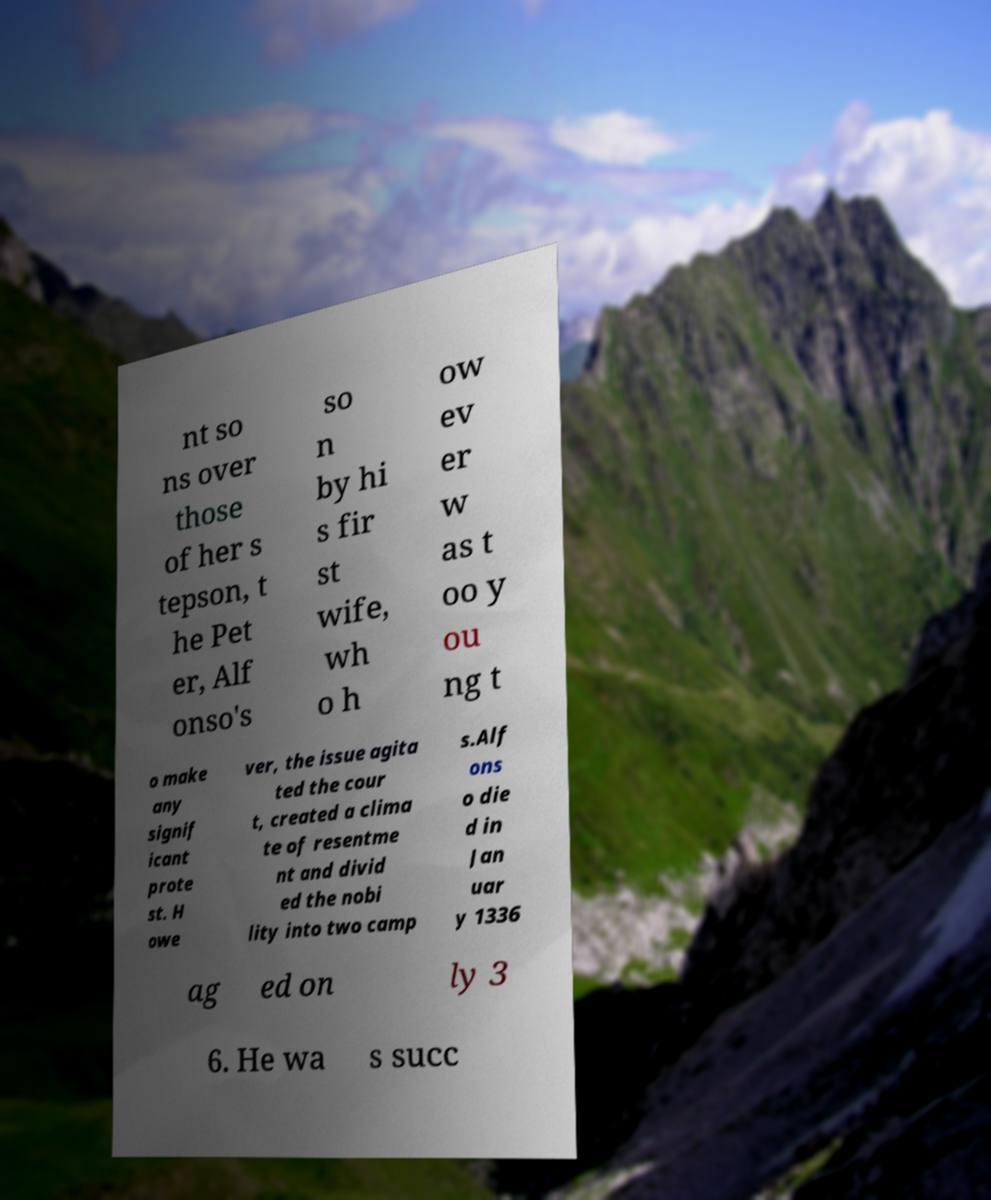Could you extract and type out the text from this image? nt so ns over those of her s tepson, t he Pet er, Alf onso's so n by hi s fir st wife, wh o h ow ev er w as t oo y ou ng t o make any signif icant prote st. H owe ver, the issue agita ted the cour t, created a clima te of resentme nt and divid ed the nobi lity into two camp s.Alf ons o die d in Jan uar y 1336 ag ed on ly 3 6. He wa s succ 